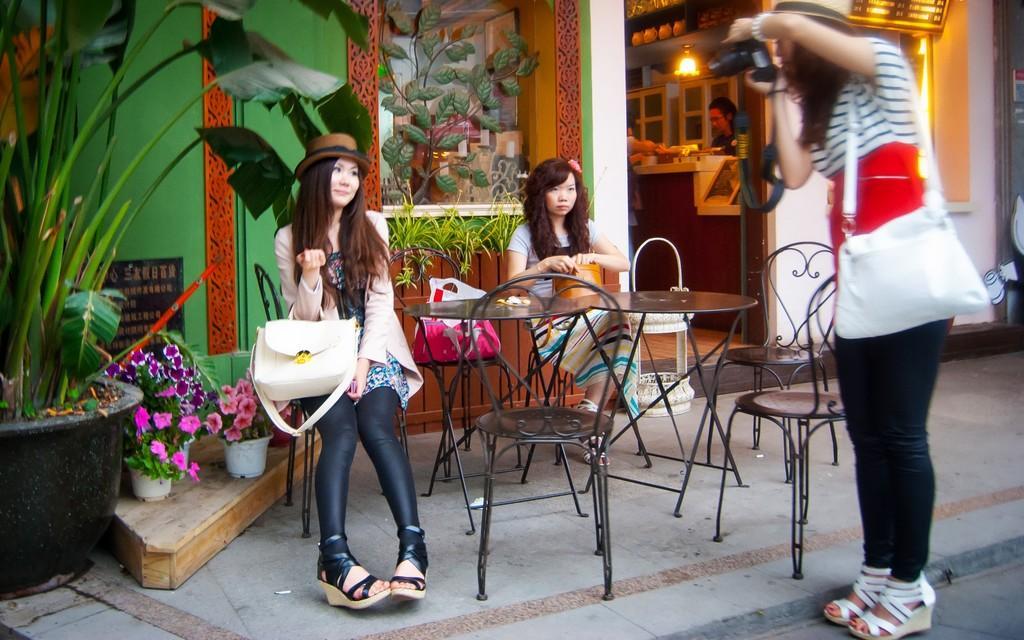Could you give a brief overview of what you see in this image? These two women are sitting on a chair. On this chair there is a plastic bag. Beside this woman there are plants. In-front of these women there are tables. Another woman is holding a camera and taking snap of this woman. In-front of that cupboard there is a person and light.  